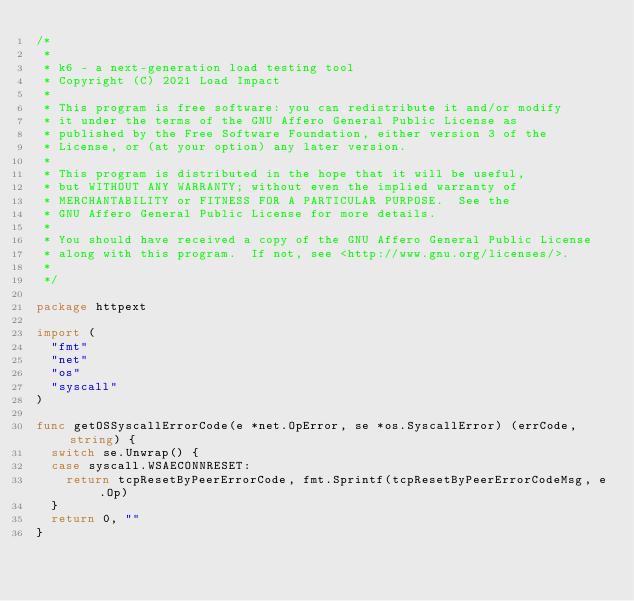Convert code to text. <code><loc_0><loc_0><loc_500><loc_500><_Go_>/*
 *
 * k6 - a next-generation load testing tool
 * Copyright (C) 2021 Load Impact
 *
 * This program is free software: you can redistribute it and/or modify
 * it under the terms of the GNU Affero General Public License as
 * published by the Free Software Foundation, either version 3 of the
 * License, or (at your option) any later version.
 *
 * This program is distributed in the hope that it will be useful,
 * but WITHOUT ANY WARRANTY; without even the implied warranty of
 * MERCHANTABILITY or FITNESS FOR A PARTICULAR PURPOSE.  See the
 * GNU Affero General Public License for more details.
 *
 * You should have received a copy of the GNU Affero General Public License
 * along with this program.  If not, see <http://www.gnu.org/licenses/>.
 *
 */

package httpext

import (
	"fmt"
	"net"
	"os"
	"syscall"
)

func getOSSyscallErrorCode(e *net.OpError, se *os.SyscallError) (errCode, string) {
	switch se.Unwrap() {
	case syscall.WSAECONNRESET:
		return tcpResetByPeerErrorCode, fmt.Sprintf(tcpResetByPeerErrorCodeMsg, e.Op)
	}
	return 0, ""
}
</code> 